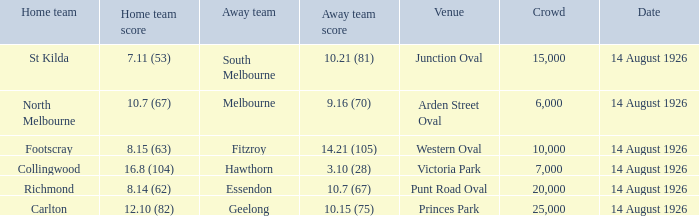What was the average crowd at Western Oval? 10000.0. 